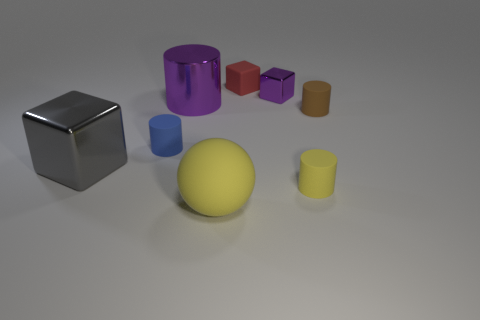Subtract all rubber blocks. How many blocks are left? 2 Subtract 2 cylinders. How many cylinders are left? 2 Subtract all brown cylinders. How many cylinders are left? 3 Add 2 large matte balls. How many objects exist? 10 Subtract all gray cylinders. Subtract all yellow blocks. How many cylinders are left? 4 Subtract all cubes. How many objects are left? 5 Subtract 0 cyan cubes. How many objects are left? 8 Subtract all tiny matte objects. Subtract all big yellow shiny balls. How many objects are left? 4 Add 8 big gray cubes. How many big gray cubes are left? 9 Add 2 big matte things. How many big matte things exist? 3 